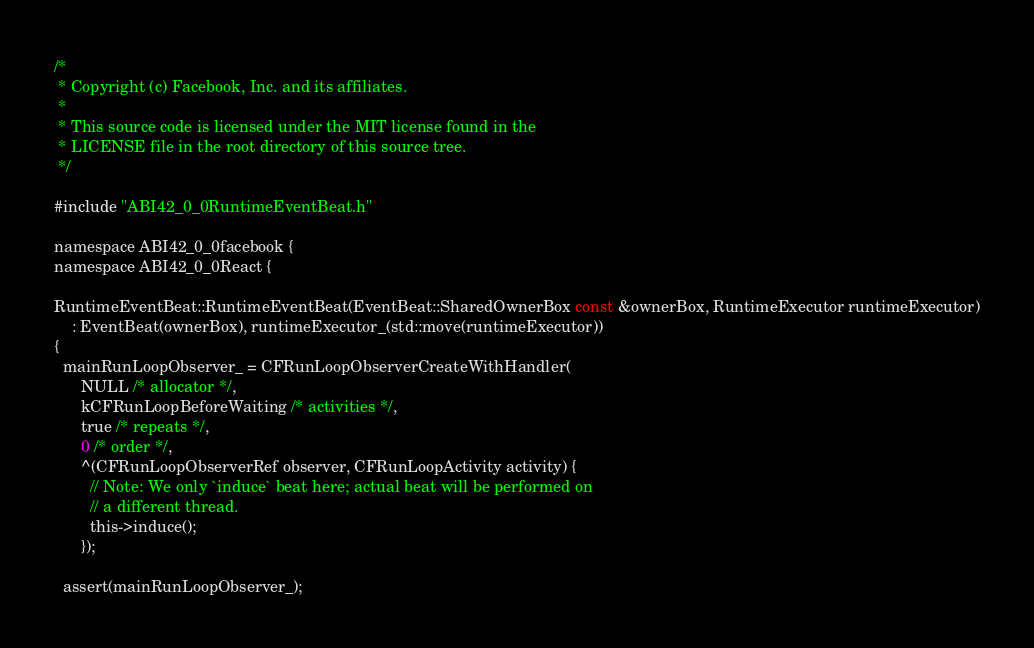<code> <loc_0><loc_0><loc_500><loc_500><_ObjectiveC_>/*
 * Copyright (c) Facebook, Inc. and its affiliates.
 *
 * This source code is licensed under the MIT license found in the
 * LICENSE file in the root directory of this source tree.
 */

#include "ABI42_0_0RuntimeEventBeat.h"

namespace ABI42_0_0facebook {
namespace ABI42_0_0React {

RuntimeEventBeat::RuntimeEventBeat(EventBeat::SharedOwnerBox const &ownerBox, RuntimeExecutor runtimeExecutor)
    : EventBeat(ownerBox), runtimeExecutor_(std::move(runtimeExecutor))
{
  mainRunLoopObserver_ = CFRunLoopObserverCreateWithHandler(
      NULL /* allocator */,
      kCFRunLoopBeforeWaiting /* activities */,
      true /* repeats */,
      0 /* order */,
      ^(CFRunLoopObserverRef observer, CFRunLoopActivity activity) {
        // Note: We only `induce` beat here; actual beat will be performed on
        // a different thread.
        this->induce();
      });

  assert(mainRunLoopObserver_);
</code> 